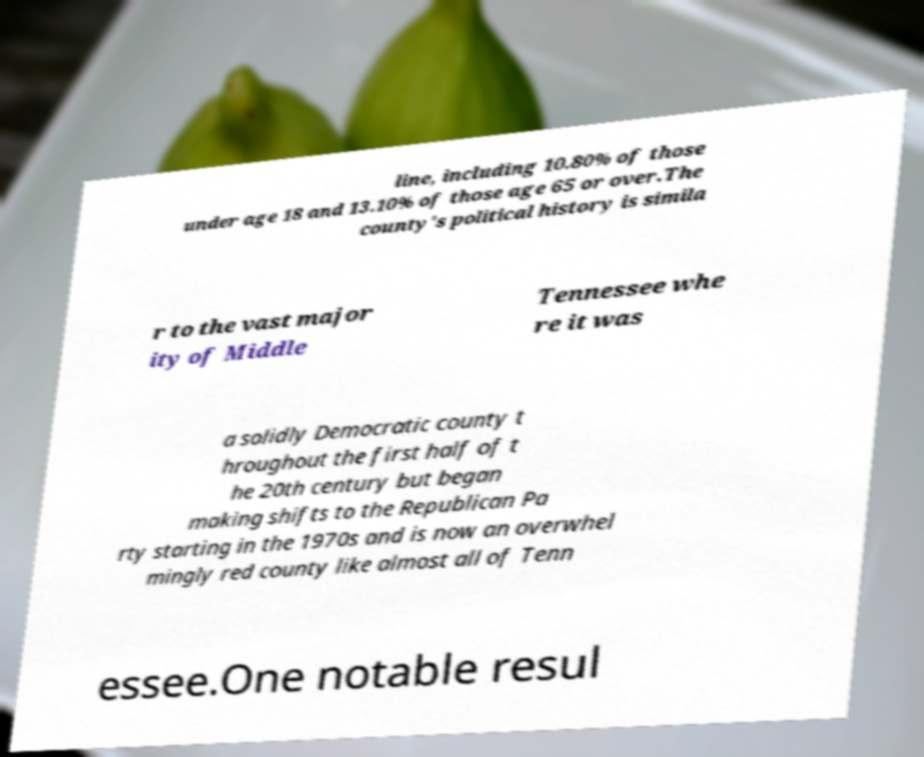Can you read and provide the text displayed in the image?This photo seems to have some interesting text. Can you extract and type it out for me? line, including 10.80% of those under age 18 and 13.10% of those age 65 or over.The county's political history is simila r to the vast major ity of Middle Tennessee whe re it was a solidly Democratic county t hroughout the first half of t he 20th century but began making shifts to the Republican Pa rty starting in the 1970s and is now an overwhel mingly red county like almost all of Tenn essee.One notable resul 